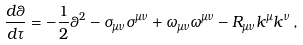<formula> <loc_0><loc_0><loc_500><loc_500>\frac { d \theta } { d \tau } = - \frac { 1 } { 2 } \theta ^ { 2 } - \sigma _ { \mu \nu } \sigma ^ { \mu \nu } + \omega _ { \mu \nu } \omega ^ { \mu \nu } - R _ { \mu \nu } k ^ { \mu } k ^ { \nu } \, ,</formula> 